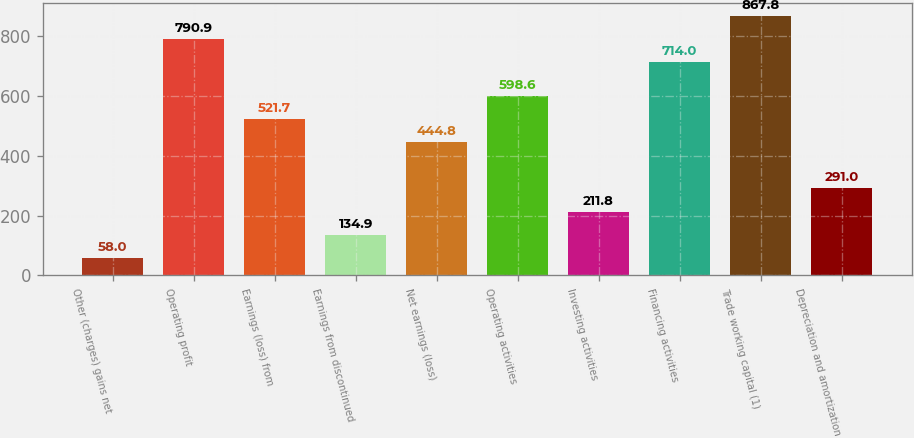Convert chart. <chart><loc_0><loc_0><loc_500><loc_500><bar_chart><fcel>Other (charges) gains net<fcel>Operating profit<fcel>Earnings (loss) from<fcel>Earnings from discontinued<fcel>Net earnings (loss)<fcel>Operating activities<fcel>Investing activities<fcel>Financing activities<fcel>Trade working capital (1)<fcel>Depreciation and amortization<nl><fcel>58<fcel>790.9<fcel>521.7<fcel>134.9<fcel>444.8<fcel>598.6<fcel>211.8<fcel>714<fcel>867.8<fcel>291<nl></chart> 